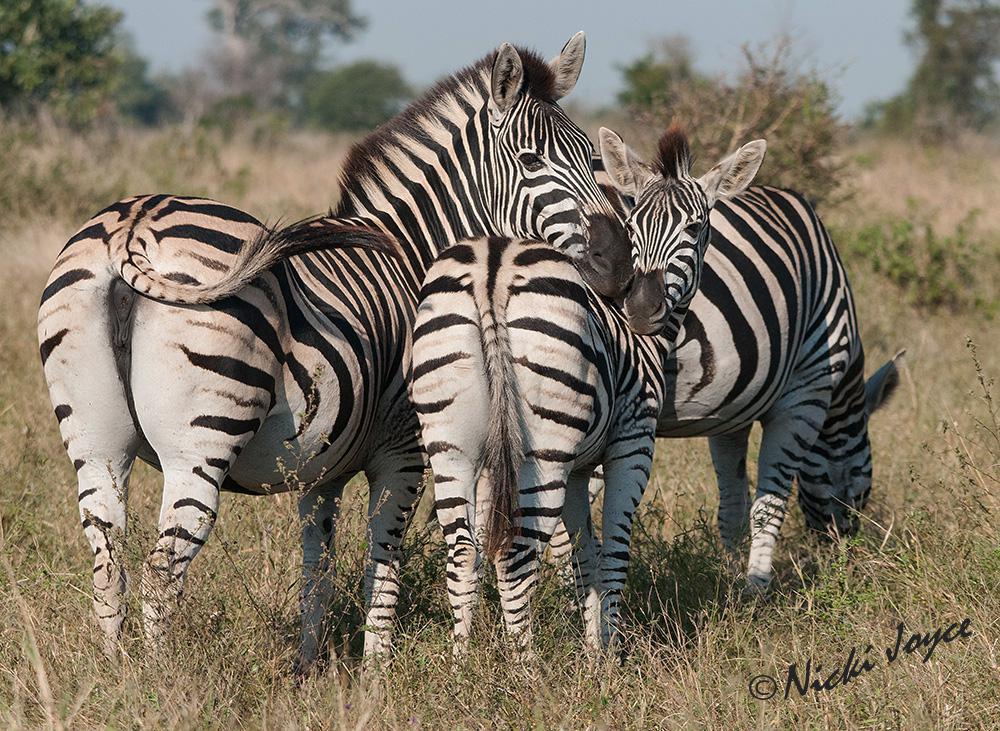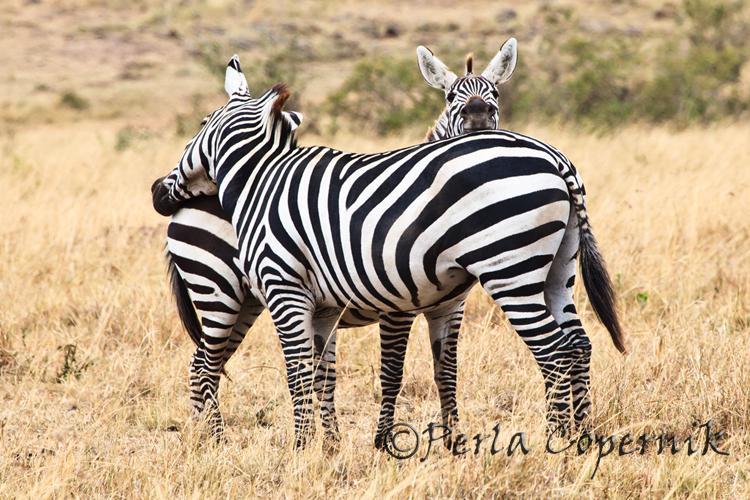The first image is the image on the left, the second image is the image on the right. Evaluate the accuracy of this statement regarding the images: "The left and right image contains a total of five zebras.". Is it true? Answer yes or no. Yes. 